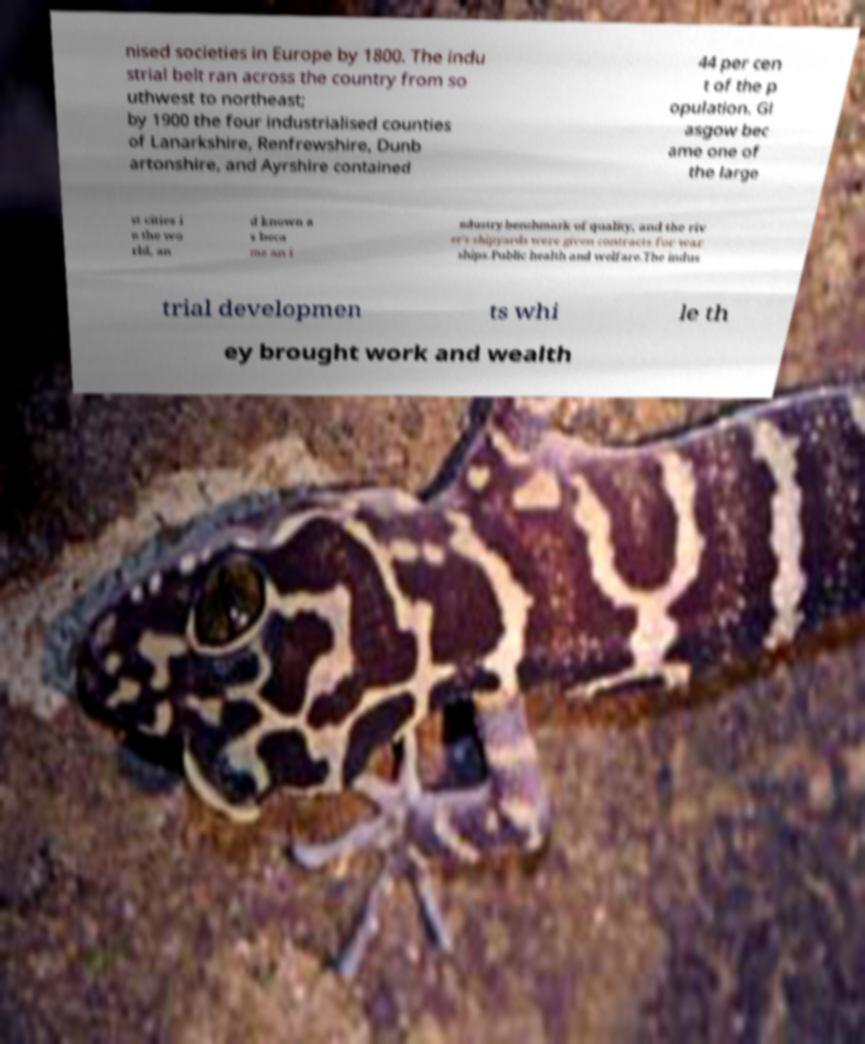Can you accurately transcribe the text from the provided image for me? nised societies in Europe by 1800. The indu strial belt ran across the country from so uthwest to northeast; by 1900 the four industrialised counties of Lanarkshire, Renfrewshire, Dunb artonshire, and Ayrshire contained 44 per cen t of the p opulation. Gl asgow bec ame one of the large st cities i n the wo rld, an d known a s beca me an i ndustry benchmark of quality, and the riv er's shipyards were given contracts for war ships.Public health and welfare.The indus trial developmen ts whi le th ey brought work and wealth 